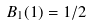<formula> <loc_0><loc_0><loc_500><loc_500>B _ { 1 } ( 1 ) = 1 / 2</formula> 